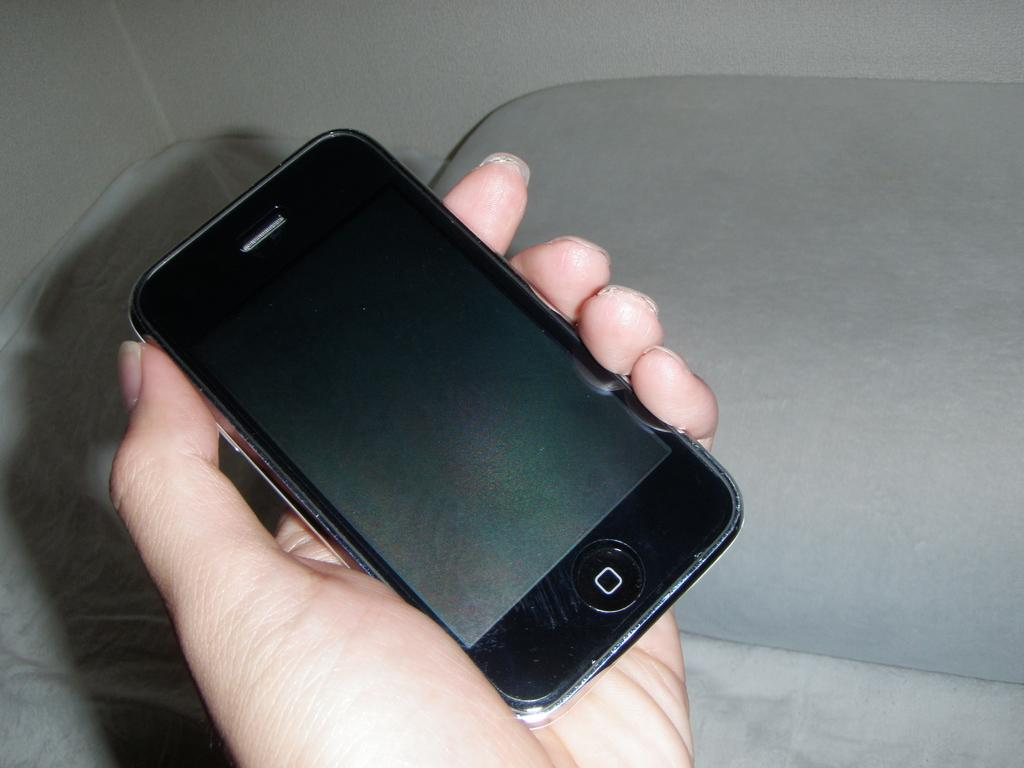Who or what is the main subject in the image? There is a person in the image. What is the person holding in the image? The person is holding a mobile in the image. How is the person holding the mobile? The person is using their hand to hold the mobile. What can be seen in the background of the image? There is a wall in the background of the image. What type of cap is the person wearing in the image? There is no cap visible in the image; the person is only holding a mobile. 